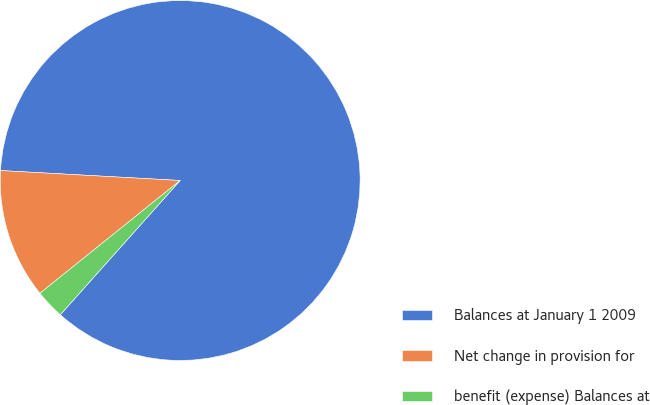Convert chart. <chart><loc_0><loc_0><loc_500><loc_500><pie_chart><fcel>Balances at January 1 2009<fcel>Net change in provision for<fcel>benefit (expense) Balances at<nl><fcel>85.72%<fcel>11.66%<fcel>2.62%<nl></chart> 